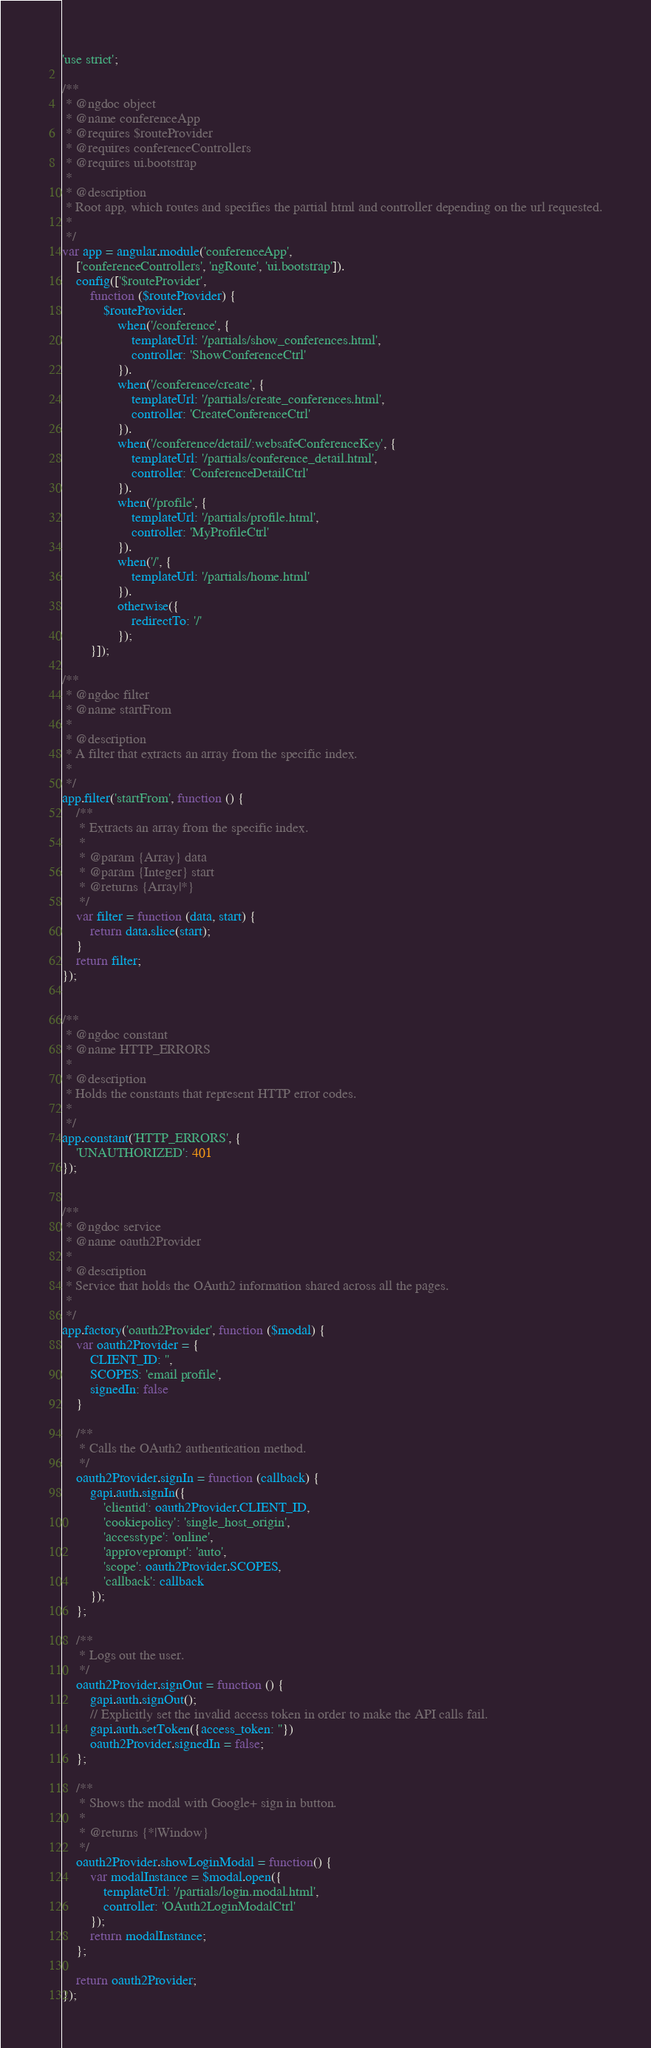Convert code to text. <code><loc_0><loc_0><loc_500><loc_500><_JavaScript_>'use strict';

/**
 * @ngdoc object
 * @name conferenceApp
 * @requires $routeProvider
 * @requires conferenceControllers
 * @requires ui.bootstrap
 *
 * @description
 * Root app, which routes and specifies the partial html and controller depending on the url requested.
 *
 */
var app = angular.module('conferenceApp',
    ['conferenceControllers', 'ngRoute', 'ui.bootstrap']).
    config(['$routeProvider',
        function ($routeProvider) {
            $routeProvider.
                when('/conference', {
                    templateUrl: '/partials/show_conferences.html',
                    controller: 'ShowConferenceCtrl'
                }).
                when('/conference/create', {
                    templateUrl: '/partials/create_conferences.html',
                    controller: 'CreateConferenceCtrl'
                }).
                when('/conference/detail/:websafeConferenceKey', {
                    templateUrl: '/partials/conference_detail.html',
                    controller: 'ConferenceDetailCtrl'
                }).
                when('/profile', {
                    templateUrl: '/partials/profile.html',
                    controller: 'MyProfileCtrl'
                }).
                when('/', {
                    templateUrl: '/partials/home.html'
                }).
                otherwise({
                    redirectTo: '/'
                });
        }]);

/**
 * @ngdoc filter
 * @name startFrom
 *
 * @description
 * A filter that extracts an array from the specific index.
 *
 */
app.filter('startFrom', function () {
    /**
     * Extracts an array from the specific index.
     *
     * @param {Array} data
     * @param {Integer} start
     * @returns {Array|*}
     */
    var filter = function (data, start) {
        return data.slice(start);
    }
    return filter;
});


/**
 * @ngdoc constant
 * @name HTTP_ERRORS
 *
 * @description
 * Holds the constants that represent HTTP error codes.
 *
 */
app.constant('HTTP_ERRORS', {
    'UNAUTHORIZED': 401
});


/**
 * @ngdoc service
 * @name oauth2Provider
 *
 * @description
 * Service that holds the OAuth2 information shared across all the pages.
 *
 */
app.factory('oauth2Provider', function ($modal) {
    var oauth2Provider = {
        CLIENT_ID: '',
        SCOPES: 'email profile',
        signedIn: false
    }

    /**
     * Calls the OAuth2 authentication method.
     */
    oauth2Provider.signIn = function (callback) {
        gapi.auth.signIn({
            'clientid': oauth2Provider.CLIENT_ID,
            'cookiepolicy': 'single_host_origin',
            'accesstype': 'online',
            'approveprompt': 'auto',
            'scope': oauth2Provider.SCOPES,
            'callback': callback
        });
    };

    /**
     * Logs out the user.
     */
    oauth2Provider.signOut = function () {
        gapi.auth.signOut();
        // Explicitly set the invalid access token in order to make the API calls fail.
        gapi.auth.setToken({access_token: ''})
        oauth2Provider.signedIn = false;
    };

    /**
     * Shows the modal with Google+ sign in button.
     *
     * @returns {*|Window}
     */
    oauth2Provider.showLoginModal = function() {
        var modalInstance = $modal.open({
            templateUrl: '/partials/login.modal.html',
            controller: 'OAuth2LoginModalCtrl'
        });
        return modalInstance;
    };

    return oauth2Provider;
});
</code> 